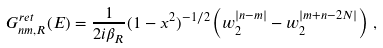<formula> <loc_0><loc_0><loc_500><loc_500>G _ { n m , R } ^ { r e t } ( E ) = \frac { 1 } { 2 i \beta _ { R } } ( 1 - x ^ { 2 } ) ^ { - 1 / 2 } \left ( w _ { 2 } ^ { | n - m | } - w _ { 2 } ^ { | m + n - 2 N | } \right ) \, ,</formula> 